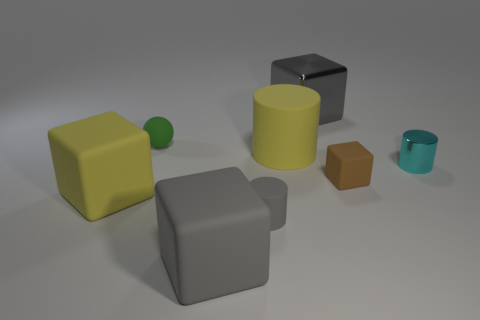What size is the block behind the matte object that is behind the yellow matte thing that is to the right of the small green matte sphere?
Provide a succinct answer. Large. There is a small gray matte object; is its shape the same as the big object that is behind the large yellow rubber cylinder?
Offer a very short reply. No. What number of other objects are there of the same size as the green sphere?
Your answer should be compact. 3. There is a gray object that is behind the tiny matte ball; how big is it?
Your answer should be compact. Large. How many brown blocks have the same material as the big yellow block?
Offer a very short reply. 1. There is a small matte thing that is to the left of the large gray matte cube; does it have the same shape as the small gray thing?
Your response must be concise. No. There is a gray thing that is behind the tiny matte cylinder; what shape is it?
Provide a short and direct response. Cube. There is a matte block that is the same color as the tiny matte cylinder; what size is it?
Give a very brief answer. Large. What is the material of the small cyan object?
Provide a succinct answer. Metal. There is another matte cube that is the same size as the gray rubber block; what color is it?
Provide a short and direct response. Yellow. 